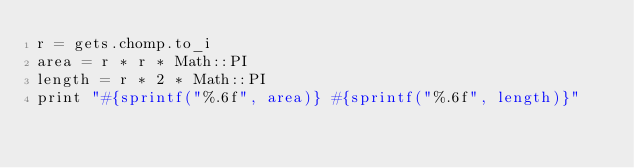<code> <loc_0><loc_0><loc_500><loc_500><_Ruby_>r = gets.chomp.to_i
area = r * r * Math::PI
length = r * 2 * Math::PI
print "#{sprintf("%.6f", area)} #{sprintf("%.6f", length)}"</code> 